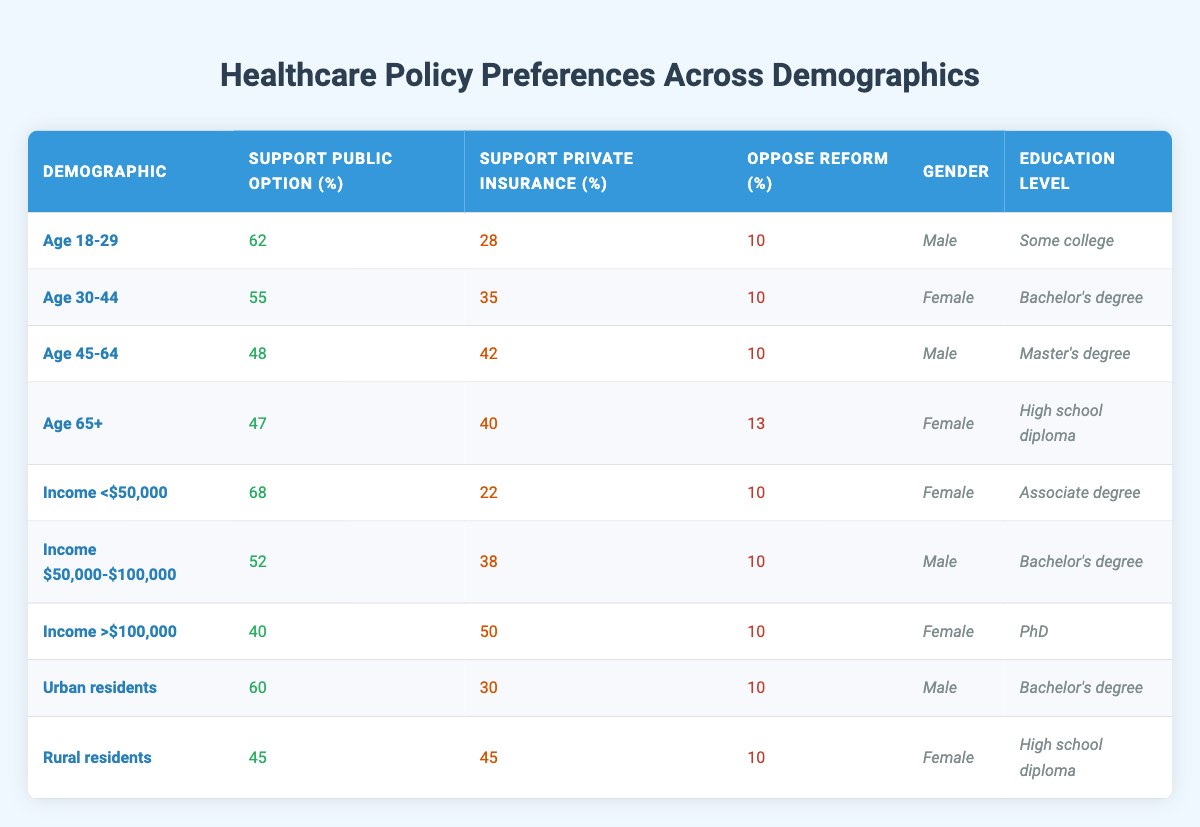What percentage of the "Age 18-29" demographic supports the public option? The table shows the "Age 18-29" demographic with 62% support for the public option noted in the corresponding column.
Answer: 62% Which demographic has the highest support for private insurance? The "Income >$100,000" demographic has 50% support for private insurance, which is higher than all other demographics listed.
Answer: Income >$100,000 How many demographics have a support percentage for the public option above 50%? The demographics with support for the public option above 50% are "Age 18-29" (62%), "Income <$50,000" (68%), and "Urban residents" (60%). That makes a total of 3 demographics.
Answer: 3 Is there a demographic that has equal support for both public and private options? The "Rural residents" demographic has equal support for public (45%) and private (45%) options, confirming the answer is yes.
Answer: Yes What is the average support for the public option across all demographics in the table? Summing all the public option supporters gives (62 + 55 + 48 + 47 + 68 + 52 + 40 + 60 + 45) = 477. With 9 demographics, the average is 477 / 9 ≈ 53. Therefore, the average support for the public option is about 53%.
Answer: 53% Compared to the "Income <$50,000" group, how much less support for the public option do "Income >$100,000" group have? The "Income <$50,000" group has 68% support, while the "Income >$100,000" group has 40%. The difference in support is 68 - 40 = 28%.
Answer: 28% Which gender demographic has the lowest support for the public option? "Income >$100,000" with a female demographic shows the lowest public option support at 40%, lower than all other listed demographics.
Answer: Female in income >$100,000 What is the relationship between education level and support for the public option in the "Age 45-64" age group? The "Age 45-64" group with a Master's degree supports the public option at 48%, which is lower than younger groups. Hence, there’s a tendency for lower education levels in older groups to show higher public support.
Answer: Lower support in older demographics Is public option support higher among females than males in the table? The total support for public options from females (from "Age 30-44," "Age 65+," "Income <$50,000," and "Income >$100,000") averages to 53.75%, while males average about 52.75%. Therefore, female support is slightly higher than male support on average.
Answer: Yes 